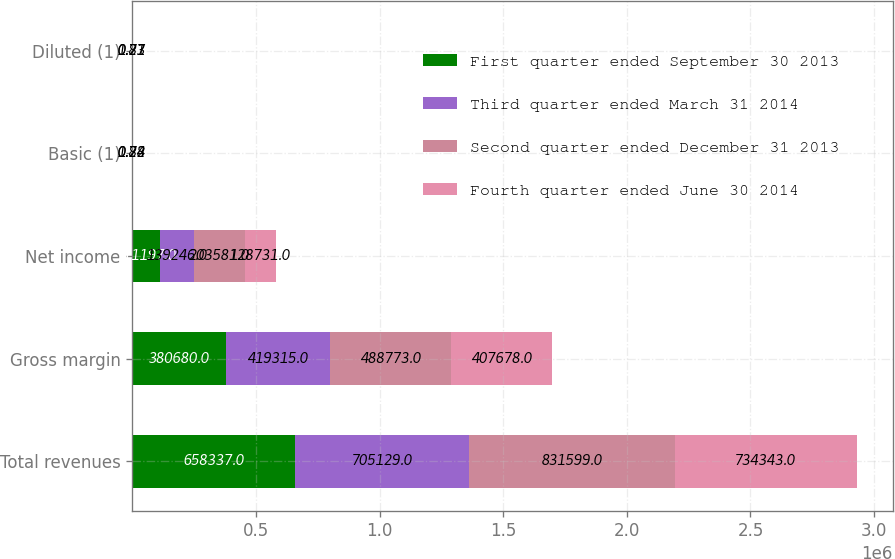Convert chart. <chart><loc_0><loc_0><loc_500><loc_500><stacked_bar_chart><ecel><fcel>Total revenues<fcel>Gross margin<fcel>Net income<fcel>Basic (1)<fcel>Diluted (1)<nl><fcel>First quarter ended September 30 2013<fcel>658337<fcel>380680<fcel>111197<fcel>0.67<fcel>0.66<nl><fcel>Third quarter ended March 31 2014<fcel>705129<fcel>419315<fcel>139246<fcel>0.84<fcel>0.83<nl><fcel>Second quarter ended December 31 2013<fcel>831599<fcel>488773<fcel>203581<fcel>1.22<fcel>1.21<nl><fcel>Fourth quarter ended June 30 2014<fcel>734343<fcel>407678<fcel>128731<fcel>0.78<fcel>0.77<nl></chart> 